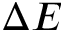Convert formula to latex. <formula><loc_0><loc_0><loc_500><loc_500>\Delta E</formula> 